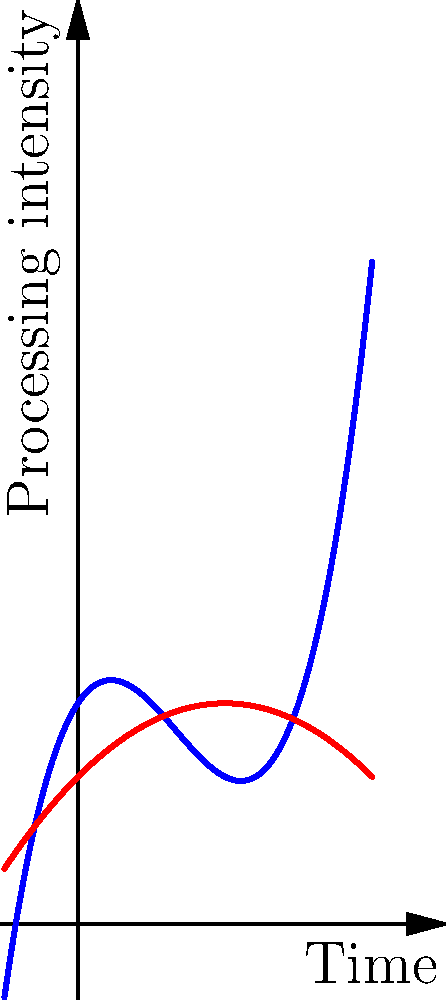Given the polynomial functions representing semantic processing (blue curve) and syntactic processing (red curve) in language comprehension, at which point in time do these processes exhibit the most significant interaction, potentially indicating a critical juncture in language processing? To determine the point of most significant interaction between semantic and syntactic processing, we need to follow these steps:

1. Identify the functions:
   - Semantic processing (blue): $f(x) = 0.5x^3 - 2x^2 + 1.5x + 3$
   - Syntactic processing (red): $g(x) = -0.25x^2 + x + 2$

2. Find the intersection point(s) of these functions by solving the equation:
   $0.5x^3 - 2x^2 + 1.5x + 3 = -0.25x^2 + x + 2$

3. Simplify:
   $0.5x^3 - 1.75x^2 + 0.5x + 1 = 0$

4. This cubic equation has one real root at approximately $x = 2$.

5. Observe the behavior of the curves around this intersection point:
   - Before $x = 2$, syntactic processing (red) is more intense.
   - After $x = 2$, semantic processing (blue) becomes more intense.
   - The rate of change for both curves is significant near this point.

6. Consider the cognitive implications:
   - This intersection represents a shift from primarily syntactic to primarily semantic processing.
   - The rapid change in both curves near this point suggests a critical transition in language processing.

Therefore, the point of most significant interaction, indicating a critical juncture in language processing, occurs at approximately $x = 2$ on the time axis.
Answer: $x = 2$ 